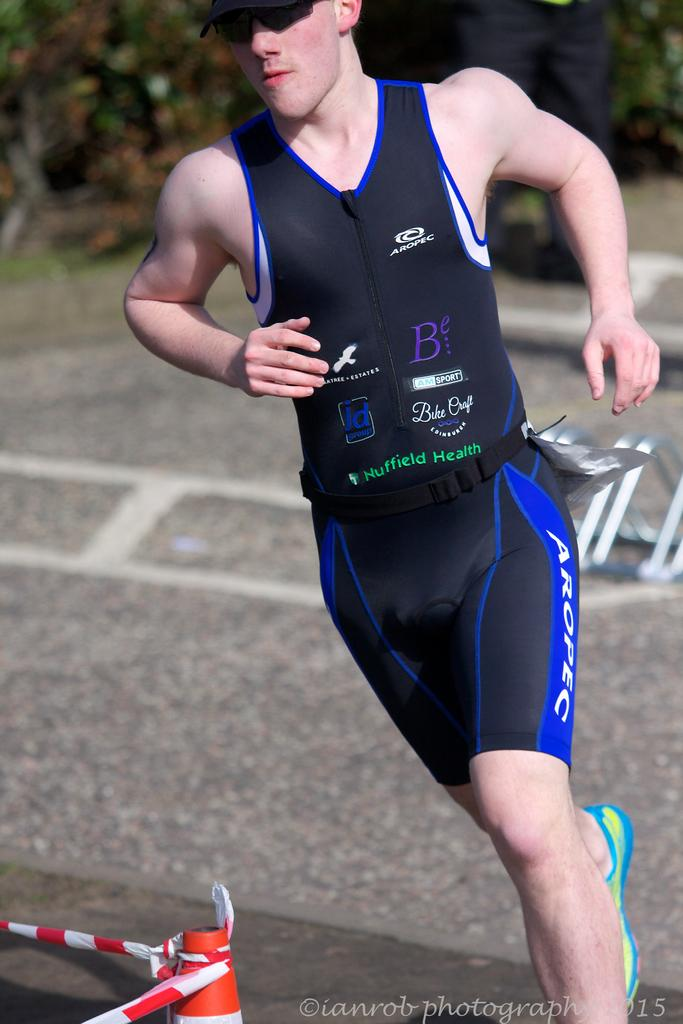<image>
Present a compact description of the photo's key features. a person wearing a running outfit with the letter B on it 